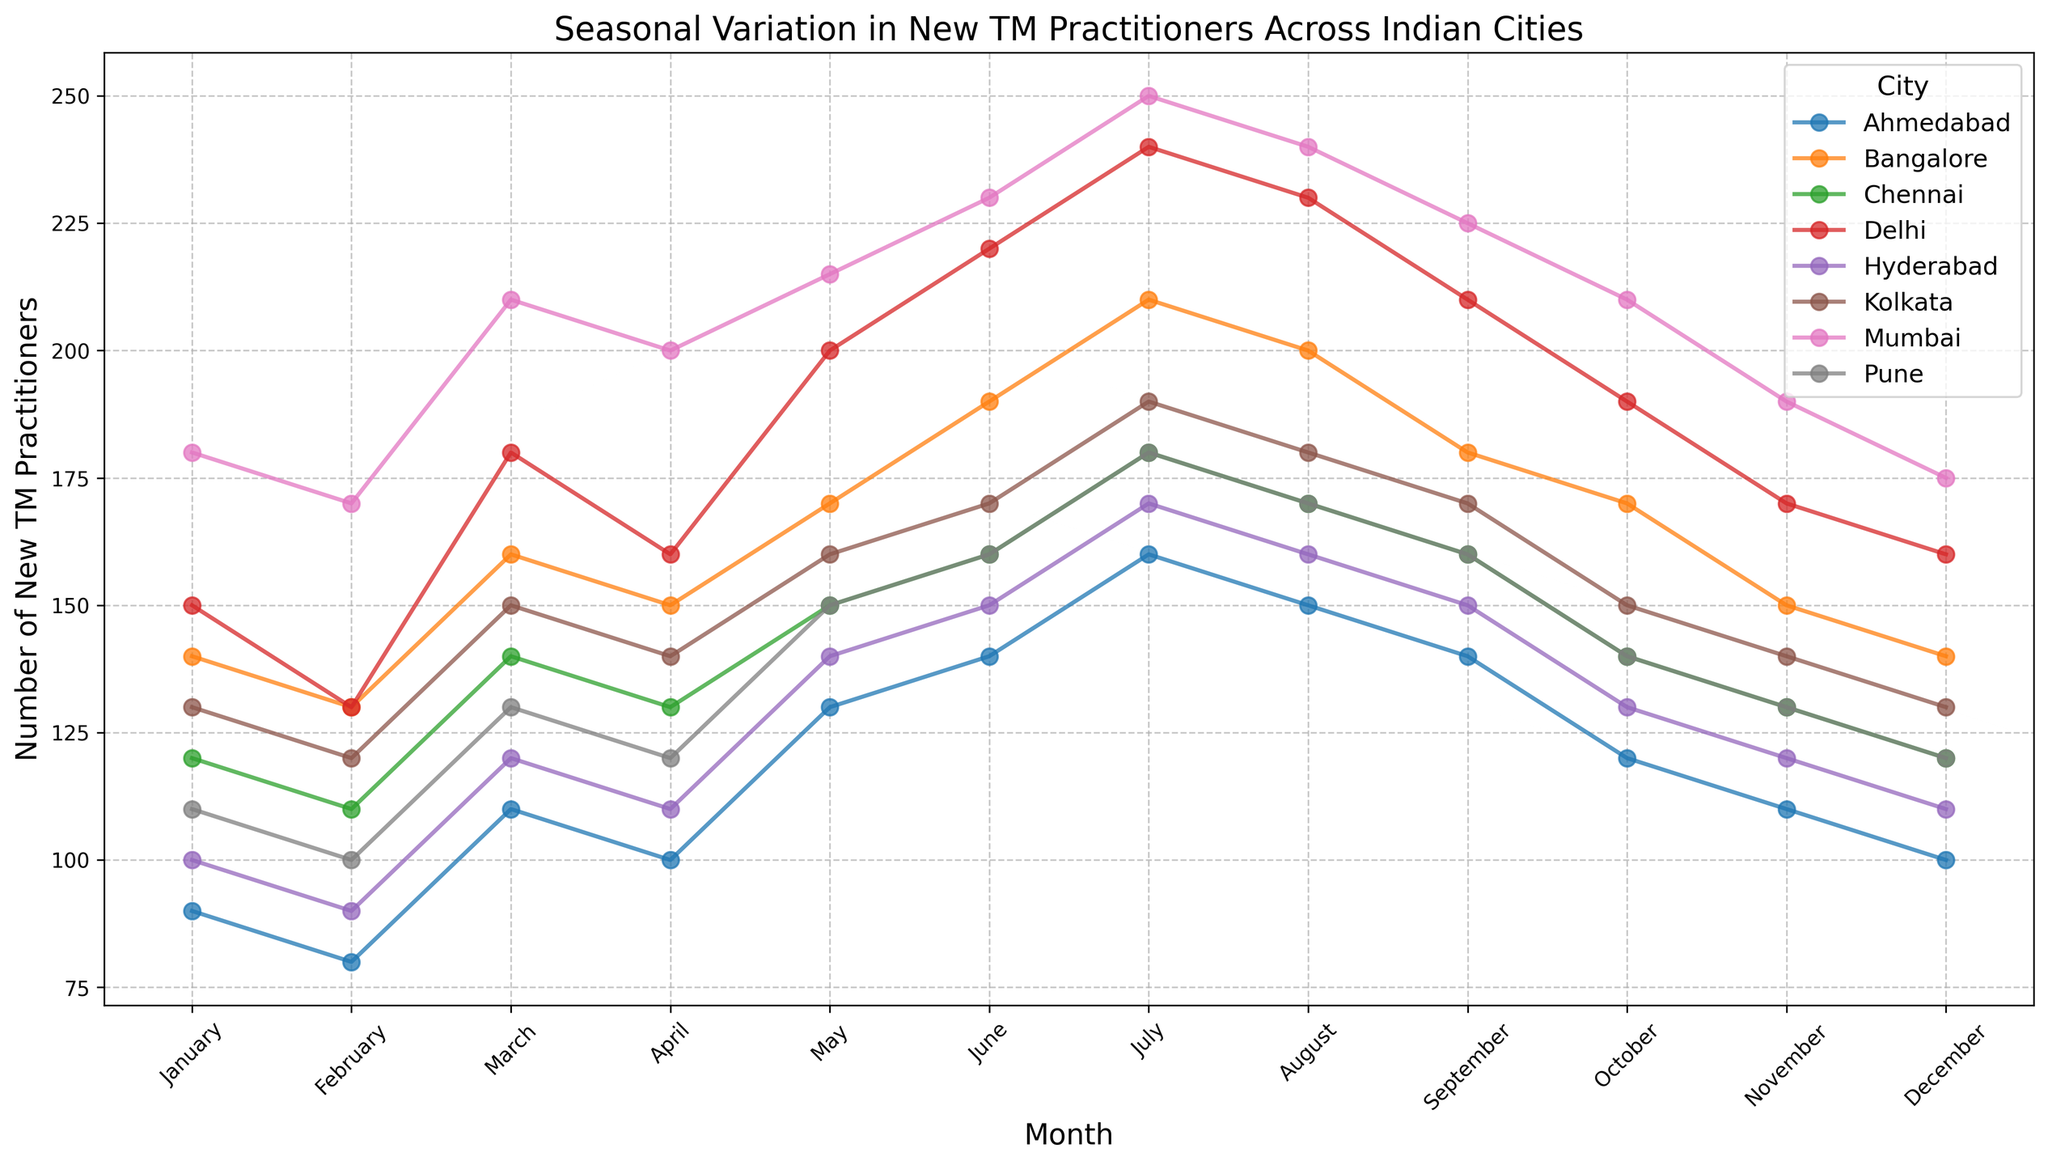Which city has the highest number of new TM practitioners in July? In July, observe the plot lines and data points. The city with the highest value is the one located at the highest point on the vertical axis for the month of July. Mumbai has the highest point.
Answer: Mumbai Which month has the lowest number of new TM practitioners in Hyderabad? Look for the lowest point on the Hyderabad line over the entire year. The lowest data point is in February.
Answer: February Compare the number of new TM practitioners in Delhi and Mumbai in May. Which city has more, and by how much? Locate the data points for May for both Delhi and Mumbai. Delhi has 200 practitioners while Mumbai has 215. Subtract the two values to find the difference: 215 - 200.
Answer: Mumbai, 15 more What is the average number of new TM practitioners in Bangalore from June to August? Identify the values for Bangalore in June, July, and August: 190, 210, and 200 respectively. Calculate the average: (190 + 210 + 200) / 3 = 200.
Answer: 200 Which month shows the greatest increase in new TM practitioners from the previous month in Chennai? Compare the differences between consecutive months for Chennai. The largest jump is between June (160) and July (180) with a difference of 20.
Answer: July During which month do Kolkata and Pune have an equal number of new TM practitioners? Look for the intersection of Kolkata and Pune lines. In September, they both have 160 new TM practitioners.
Answer: September Which city shows the least variation in new TM practitioners over the year? Visually inspect the plot lines for which line appears the most stable (least fluctuation). Chennai’s line shows the least variation.
Answer: Chennai Calculate the total number of new TM practitioners in Ahmedabad over the entire year. Sum the monthly values for Ahmedabad: 90 + 80 + 110 + 100 + 130 + 140 + 160 + 150 + 140 + 120 + 110 + 100 = 1430.
Answer: 1430 How does the number of new TM practitioners in January compare across all cities? Observe the height of the data points for January across all city lines. Mumbai has the highest with 180, followed by Delhi, Kolkata, Bangalore, Pune, Chennai, Hyderabad, and finally Ahmedabad with 90.
Answer: Mumbai, highest; Ahmedabad, lowest In which month does Pune have the highest number of new TM practitioners, and what is the number? Find the peak value on the Pune line. The peak occurs in July with 180 practitioners.
Answer: July, 180 